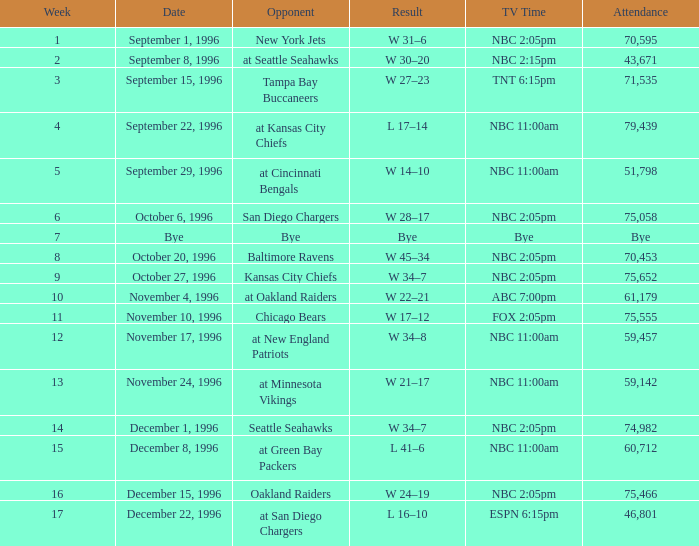During which week did 75,555 people attend? 11.0. 